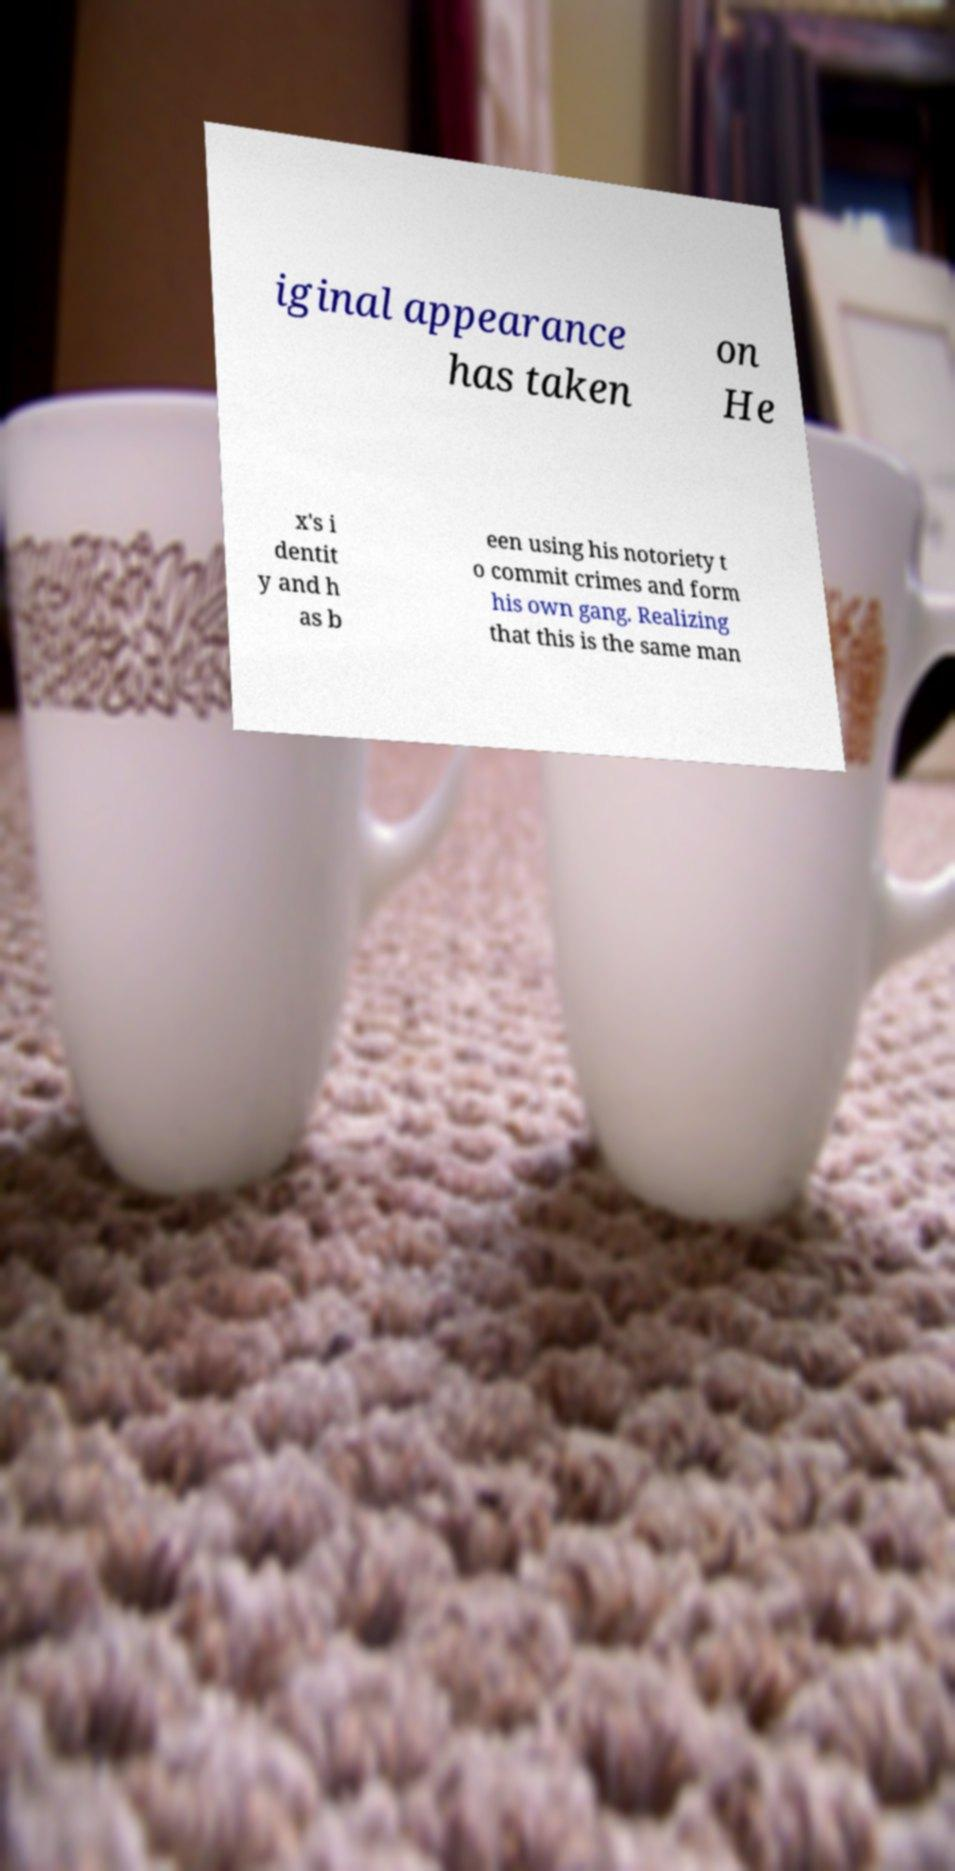Please read and relay the text visible in this image. What does it say? iginal appearance has taken on He x's i dentit y and h as b een using his notoriety t o commit crimes and form his own gang. Realizing that this is the same man 